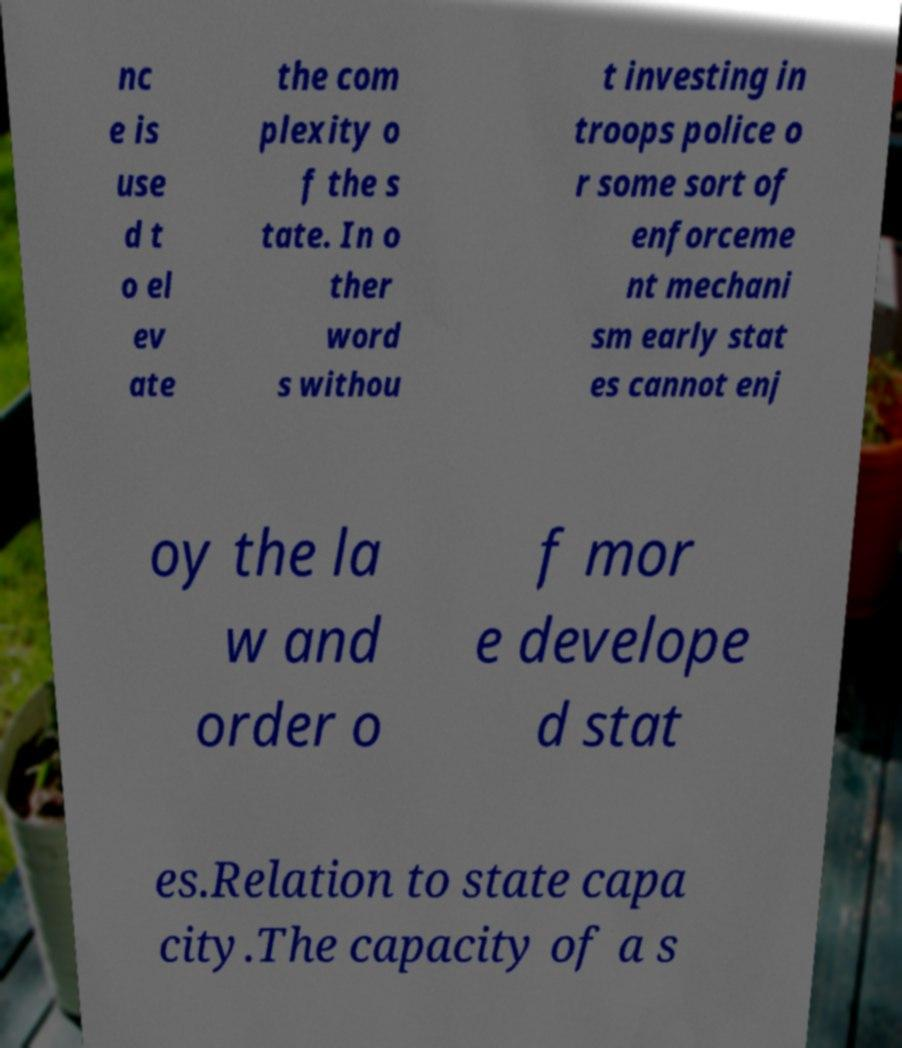Could you extract and type out the text from this image? nc e is use d t o el ev ate the com plexity o f the s tate. In o ther word s withou t investing in troops police o r some sort of enforceme nt mechani sm early stat es cannot enj oy the la w and order o f mor e develope d stat es.Relation to state capa city.The capacity of a s 